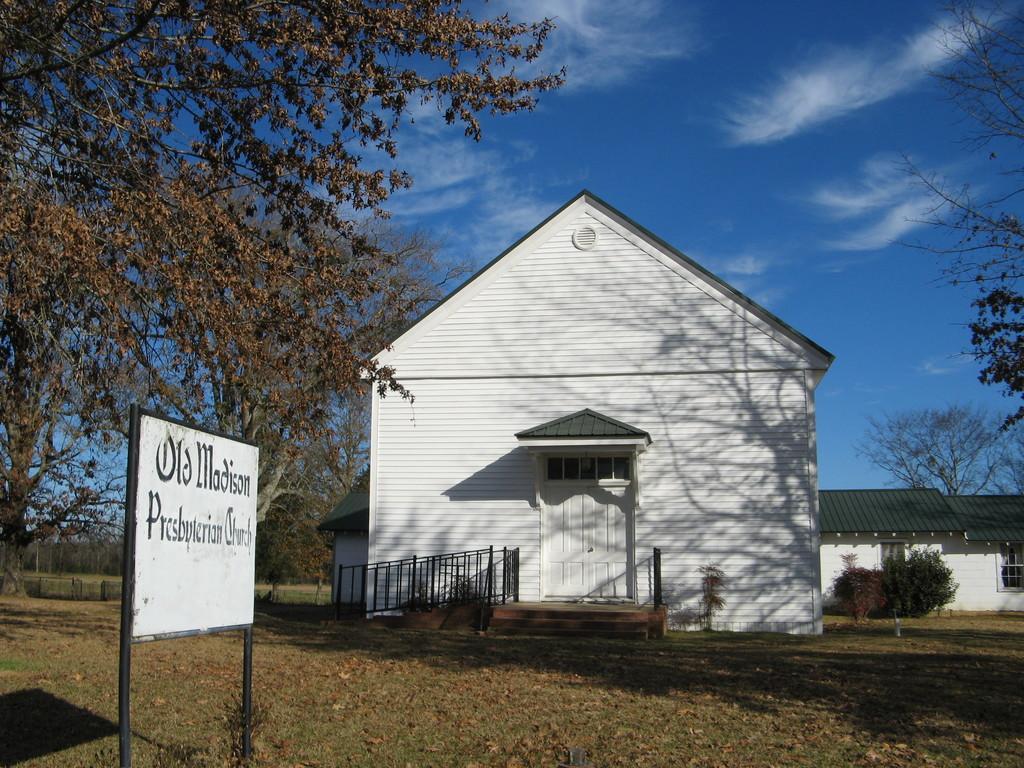Could you give a brief overview of what you see in this image? We can see board on poles and grass and we can see trees. In the background we can see houses,plants,trees and sky with clouds. 